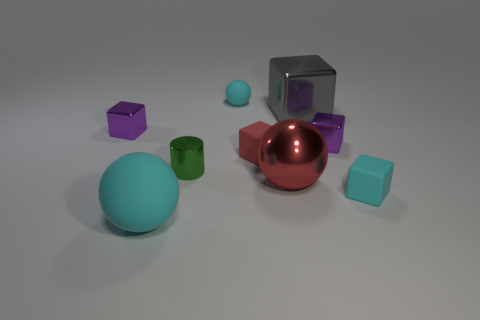Subtract all big balls. How many balls are left? 1 Subtract all blocks. How many objects are left? 4 Add 1 metallic cylinders. How many metallic cylinders exist? 2 Subtract all red balls. How many balls are left? 2 Subtract 0 cyan cylinders. How many objects are left? 9 Subtract 1 cubes. How many cubes are left? 4 Subtract all yellow cylinders. Subtract all yellow spheres. How many cylinders are left? 1 Subtract all cyan cylinders. How many red spheres are left? 1 Subtract all large metal things. Subtract all small blue rubber spheres. How many objects are left? 7 Add 1 small red rubber objects. How many small red rubber objects are left? 2 